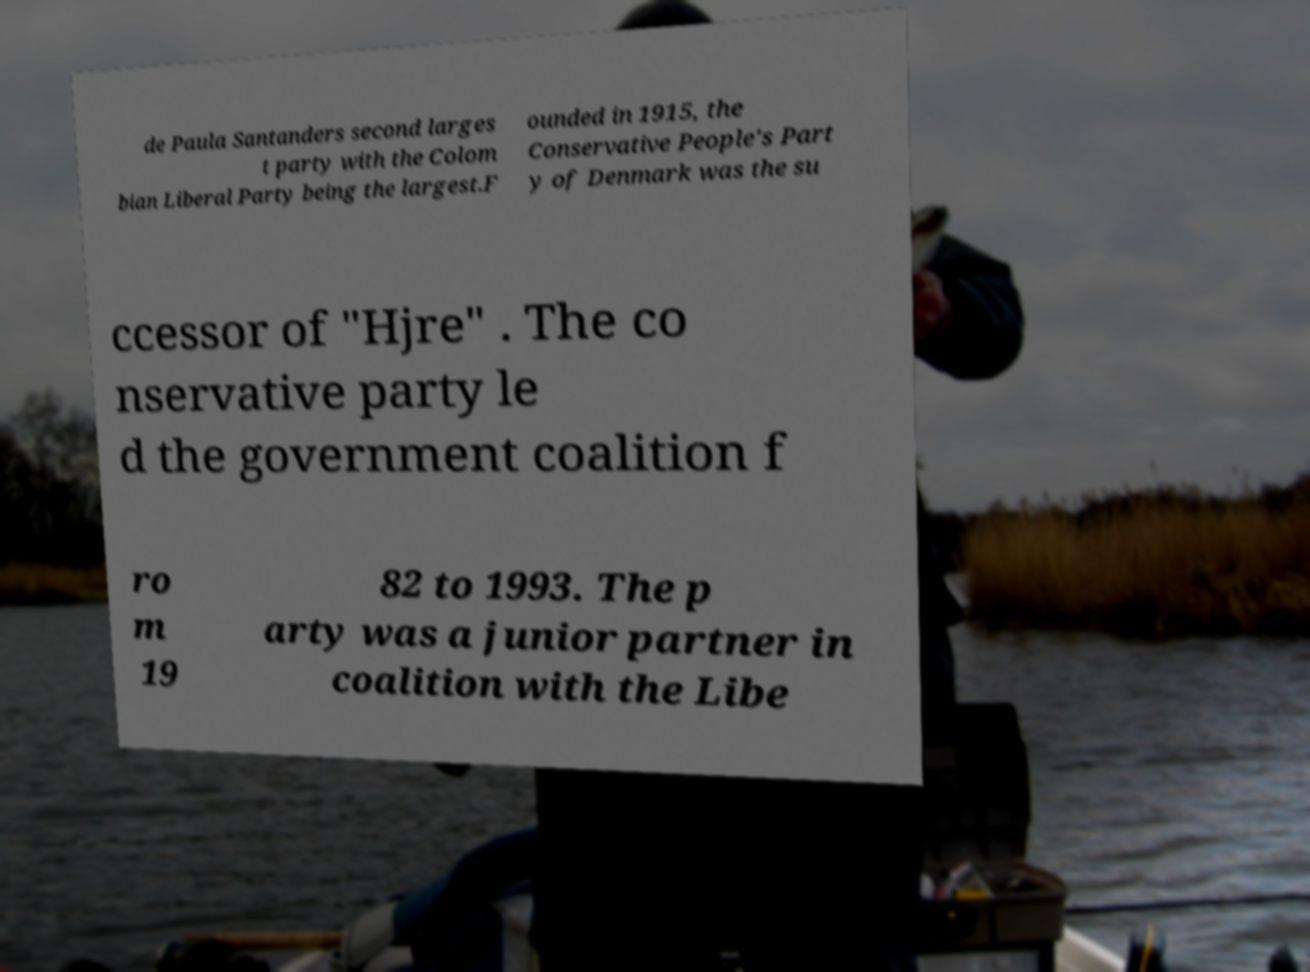I need the written content from this picture converted into text. Can you do that? de Paula Santanders second larges t party with the Colom bian Liberal Party being the largest.F ounded in 1915, the Conservative People's Part y of Denmark was the su ccessor of "Hjre" . The co nservative party le d the government coalition f ro m 19 82 to 1993. The p arty was a junior partner in coalition with the Libe 